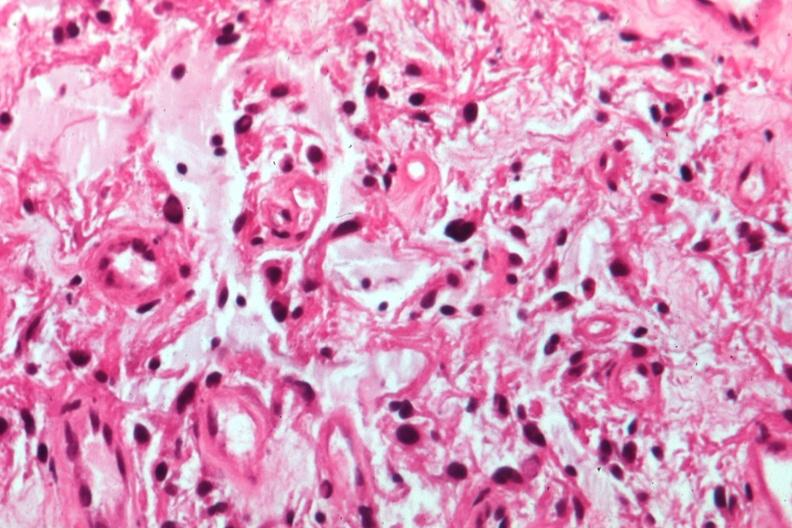what is present?
Answer the question using a single word or phrase. Eye 